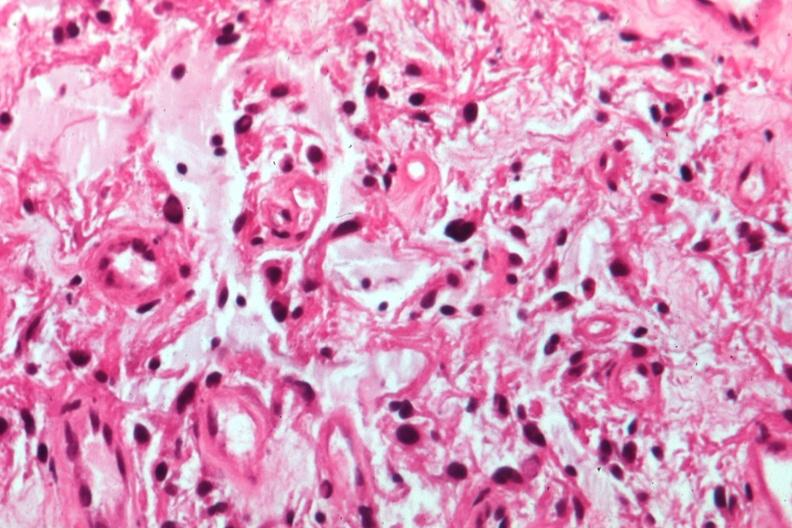what is present?
Answer the question using a single word or phrase. Eye 